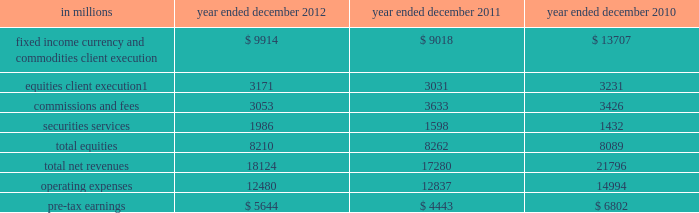Management 2019s discussion and analysis the table below presents the operating results of our institutional client services segment. .
Includes net revenues related to reinsurance of $ 1.08 billion , $ 880 million and $ 827 million for the years ended december 2012 , december 2011 and december 2010 , respectively .
2012 versus 2011 .
Net revenues in institutional client services were $ 18.12 billion for 2012 , 5% ( 5 % ) higher than 2011 .
Net revenues in fixed income , currency and commodities client execution were $ 9.91 billion for 2012 , 10% ( 10 % ) higher than 2011 .
These results reflected strong net revenues in mortgages , which were significantly higher compared with 2011 .
In addition , net revenues in credit products and interest rate products were solid and higher compared with 2011 .
These increases were partially offset by significantly lower net revenues in commodities and slightly lower net revenues in currencies .
Although broad market concerns persisted during 2012 , fixed income , currency and commodities client execution operated in a generally improved environment characterized by tighter credit spreads and less challenging market-making conditions compared with 2011 .
Net revenues in equities were $ 8.21 billion for 2012 , essentially unchanged compared with 2011 .
Net revenues in securities services were significantly higher compared with 2011 , reflecting a gain of approximately $ 500 million on the sale of our hedge fund administration business .
In addition , equities client execution net revenues were higher than 2011 , primarily reflecting significantly higher results in cash products , principally due to increased levels of client activity .
These increases were offset by lower commissions and fees , reflecting lower market volumes .
During 2012 , equities operated in an environment generally characterized by an increase in global equity prices and lower volatility levels .
The net loss attributable to the impact of changes in our own credit spreads on borrowings for which the fair value option was elected was $ 714 million ( $ 433 million and $ 281 million related to fixed income , currency and commodities client execution and equities client execution , respectively ) for 2012 , compared with a net gain of $ 596 million ( $ 399 million and $ 197 million related to fixed income , currency and commodities client execution and equities client execution , respectively ) for 2011 .
During 2012 , institutional client services operated in an environment generally characterized by continued broad market concerns and uncertainties , although positive developments helped to improve market conditions .
These developments included certain central bank actions to ease monetary policy and address funding risks for european financial institutions .
In addition , the u.s .
Economy posted stable to improving economic data , including favorable developments in unemployment and housing .
These improvements resulted in tighter credit spreads , higher global equity prices and lower levels of volatility .
However , concerns about the outlook for the global economy and continued political uncertainty , particularly the political debate in the united states surrounding the fiscal cliff , generally resulted in client risk aversion and lower activity levels .
Also , uncertainty over financial regulatory reform persisted .
If these concerns and uncertainties continue over the long term , net revenues in fixed income , currency and commodities client execution and equities would likely be negatively impacted .
Operating expenses were $ 12.48 billion for 2012 , 3% ( 3 % ) lower than 2011 , primarily due to lower brokerage , clearing , exchange and distribution fees , and lower impairment charges , partially offset by higher net provisions for litigation and regulatory proceedings .
Pre-tax earnings were $ 5.64 billion in 2012 , 27% ( 27 % ) higher than 2011 .
2011 versus 2010 .
Net revenues in institutional client services were $ 17.28 billion for 2011 , 21% ( 21 % ) lower than 2010 .
Net revenues in fixed income , currency and commodities client execution were $ 9.02 billion for 2011 , 34% ( 34 % ) lower than 2010 .
Although activity levels during 2011 were generally consistent with 2010 levels , and results were solid during the first quarter of 2011 , the environment during the remainder of 2011 was characterized by broad market concerns and uncertainty , resulting in volatile markets and significantly wider credit spreads , which contributed to difficult market-making conditions and led to reductions in risk by us and our clients .
As a result of these conditions , net revenues across the franchise were lower , including significant declines in mortgages and credit products , compared with 2010 .
54 goldman sachs 2012 annual report .
Of operating results of the institutional client services segment , in millions , what percentage of equities client execution for 2012 relates to net revenues related to reinsurance? 
Computations: (1.08 * 1000)
Answer: 1080.0. 